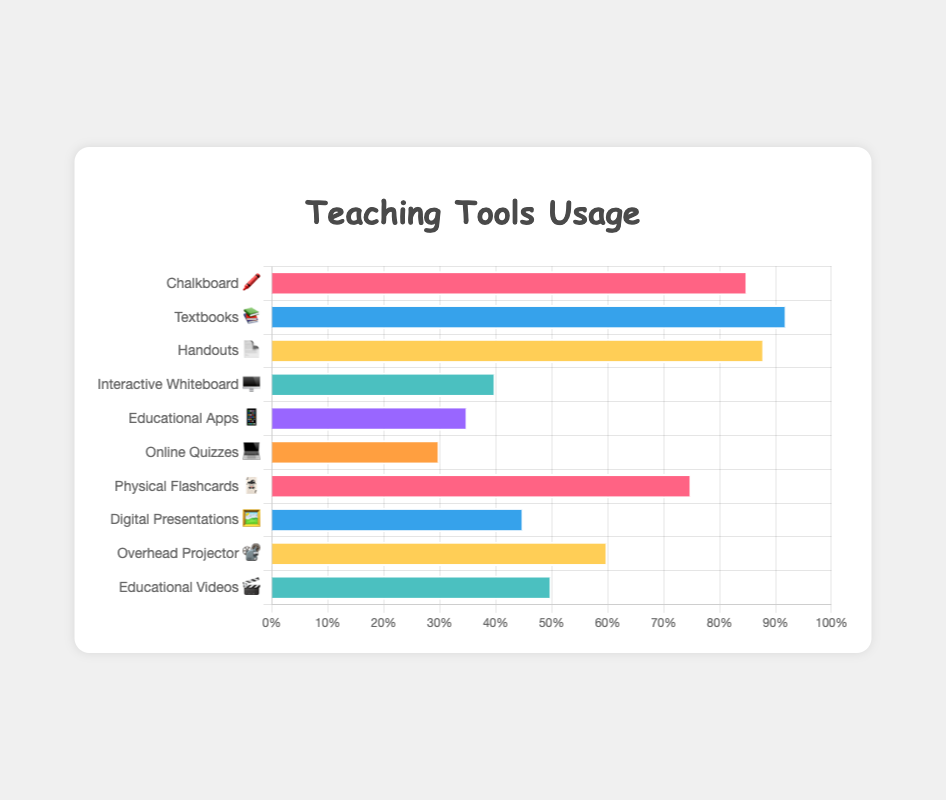How many tools in total are shown in the chart? Count the total number of items in the list of tools. We have "Chalkboard 🖍️", "Textbooks 📚", "Handouts 📄", "Interactive Whiteboard 🖥️", "Educational Apps 📱", "Online Quizzes 💻", "Physical Flashcards 🃏", "Digital Presentations 🖼️", "Overhead Projector 📽️", and "Educational Videos 🎬" which adds up to 10
Answer: 10 What is the title of the chart? Look at the text centered above the chart. It reads "Teaching Tools Usage"
Answer: Teaching Tools Usage Which tool has the highest usage percentage? The highest value in the dataset is 92, which corresponds to "Textbooks 📚"
Answer: Textbooks 📚 What percentage of teachers use Educational Apps 📱? Find "Educational Apps 📱" in the data and look at its percentage value, which is 35%
Answer: 35% Is the usage percentage of Digital Presentations 🖼️ higher or lower than Handouts 📄? Compare the percentages for "Digital Presentations 🖼️" (45%) and "Handouts 📄" (88%). 45% is lower than 88%
Answer: Lower What is the difference in percentage usage between Chalkboard 🖍️ and Educational Videos 🎬? Subtract the percentage of "Educational Videos 🎬" (50%) from "Chalkboard 🖍️" (85%) to get 85% - 50% = 35%
Answer: 35% What is the average usage percentage of all the digital tools listed (Interactive Whiteboard 🖥️, Educational Apps 📱, Online Quizzes 💻, Digital Presentations 🖼️, Educational Videos 🎬)? Add the percentages of the digital tools (40 + 35 + 30 + 45 + 50 = 200) and divide by the number of tools (5). The average usage percentage is 200/5 = 40%
Answer: 40% Which digital tool has the least usage percentage? Compare the percentages of all digital tools. The lowest is 30%, which corresponds to "Online Quizzes 💻"
Answer: Online Quizzes 💻 How many tools have a usage percentage greater than 50%? Count the tools with percentages higher than 50%. These are: "Chalkboard 🖍️", "Textbooks 📚", "Handouts 📄", "Physical Flashcards 🃏", and "Overhead Projector 📽️". This adds up to 5 tools
Answer: 5 What is the usage percentage difference between Overhead Projector 📽️ and Interactive Whiteboard 🖥️? Subtract the percentage of "Interactive Whiteboard 🖥️" (40%) from "Overhead Projector 📽️" (60%) to get 60% - 40% = 20%
Answer: 20% 